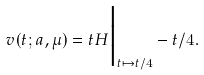Convert formula to latex. <formula><loc_0><loc_0><loc_500><loc_500>v ( t ; a , \mu ) = t H \Big | _ { t \mapsto t / 4 } - t / 4 .</formula> 